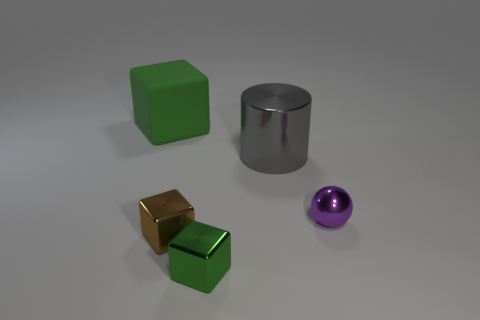There is a brown object that is the same shape as the large green matte thing; what is it made of?
Your response must be concise. Metal. There is a green block that is behind the green thing on the right side of the brown object; what size is it?
Offer a terse response. Large. Are there any metallic cylinders?
Give a very brief answer. Yes. What is the material of the thing that is both behind the small purple object and to the left of the big shiny object?
Your response must be concise. Rubber. Is the number of metallic objects in front of the large metallic cylinder greater than the number of brown things right of the small brown cube?
Keep it short and to the point. Yes. Are there any other green matte blocks of the same size as the green rubber cube?
Give a very brief answer. No. There is a green thing that is right of the block behind the small metallic block that is behind the tiny green metallic thing; what size is it?
Your answer should be very brief. Small. What is the color of the matte object?
Offer a very short reply. Green. Is the number of metal things behind the brown block greater than the number of brown objects?
Offer a terse response. Yes. What number of tiny brown metallic things are left of the large gray cylinder?
Your answer should be very brief. 1. 